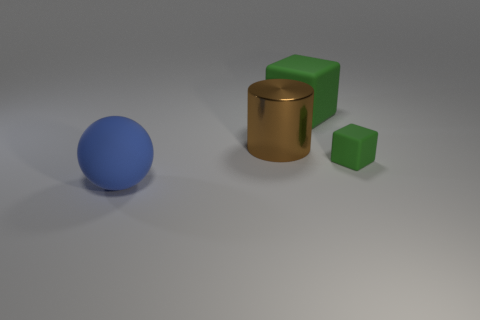Add 1 tiny green blocks. How many objects exist? 5 Subtract all spheres. How many objects are left? 3 Subtract 1 cylinders. How many cylinders are left? 0 Add 1 tiny blocks. How many tiny blocks exist? 2 Subtract 0 yellow cylinders. How many objects are left? 4 Subtract all brown spheres. Subtract all cyan blocks. How many spheres are left? 1 Subtract all blocks. Subtract all blue objects. How many objects are left? 1 Add 4 brown things. How many brown things are left? 5 